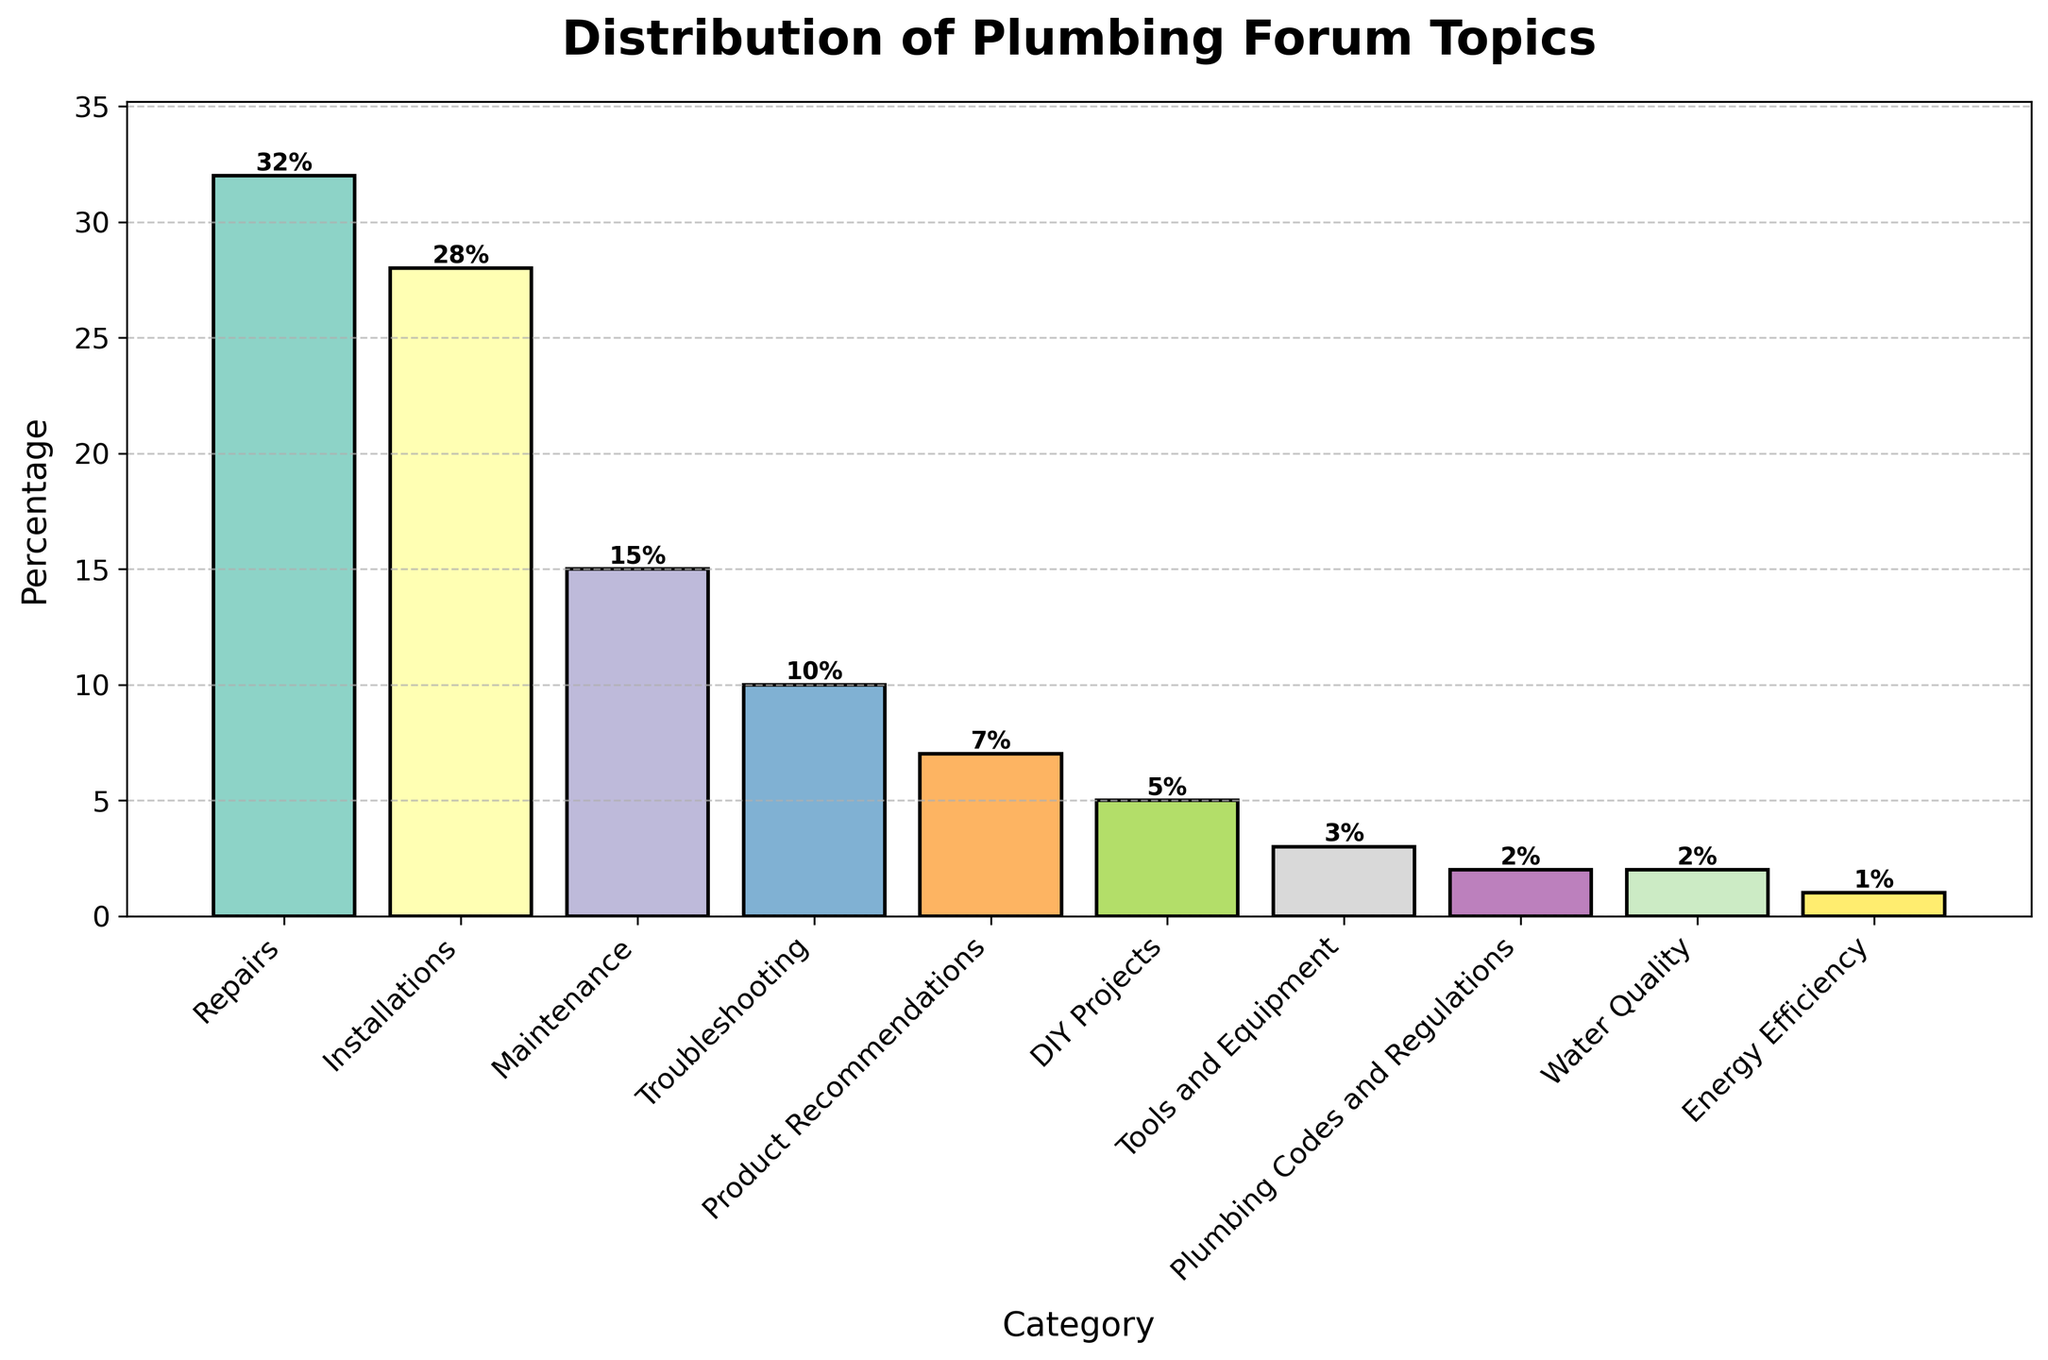Which category has the highest percentage of topics? The bar chart shows the heights of each bar representing the percentage of topics per category. Among these, the 'Repairs' category has the tallest bar indicating the highest percentage.
Answer: Repairs What's the combined percentage of topics for 'DIY Projects' and 'Tools and Equipment'? The bar chart shows the percentage for 'DIY Projects' is 5% and for 'Tools and Equipment' is 3%. Summing these, 5 + 3 = 8
Answer: 8 How much higher is the percentage of 'Maintenance' topics compared to 'Plumbing Codes and Regulations' topics? The chart shows 'Maintenance' at 15% and 'Plumbing Codes and Regulations' at 2%. The difference between them is 15 - 2 = 13
Answer: 13 Which category has the smallest percentage of topics? The shortest bar in the chart represents the smallest percentage, which corresponds to 'Energy Efficiency' with 1%.
Answer: Energy Efficiency If you combine 'Water Quality' and 'Energy Efficiency' categories, what percentage do they account for? The chart indicates 'Water Quality' at 2% and 'Energy Efficiency' at 1%. Summing these, 2 + 1 = 3
Answer: 3 Are there more topics in 'Installations' or 'Troubleshooting'? The bar for 'Installations' is taller and marked at 28%, whereas the bar for 'Troubleshooting' is marked at 10%. Therefore, 'Installations' has more topics.
Answer: Installations How does the percentage of 'Product Recommendations' topics compare to 'DIY Projects' topics? The bar chart shows 'Product Recommendations' at 7% and 'DIY Projects' at 5%. Hence, 'Product Recommendations' has a higher percentage by 2%.
Answer: Product Recommendations What is the difference in percentage points between 'Repairs' and 'Maintenance'? According to the chart, 'Repairs' has 32% and 'Maintenance' has 15%. The difference is 32 - 15 = 17.
Answer: 17 What percentage of topics does the 'Troubleshooting' category account for? The bar chart shows the percentage for 'Troubleshooting' is 10%, as indicated on the corresponding bar.
Answer: 10 What's the sum of the percentages for 'Plumbing Codes and Regulations' and 'Water Quality'? The chart shows 'Plumbing Codes and Regulations' at 2% and 'Water Quality' at 2%. Summing these, 2 + 2 = 4
Answer: 4 